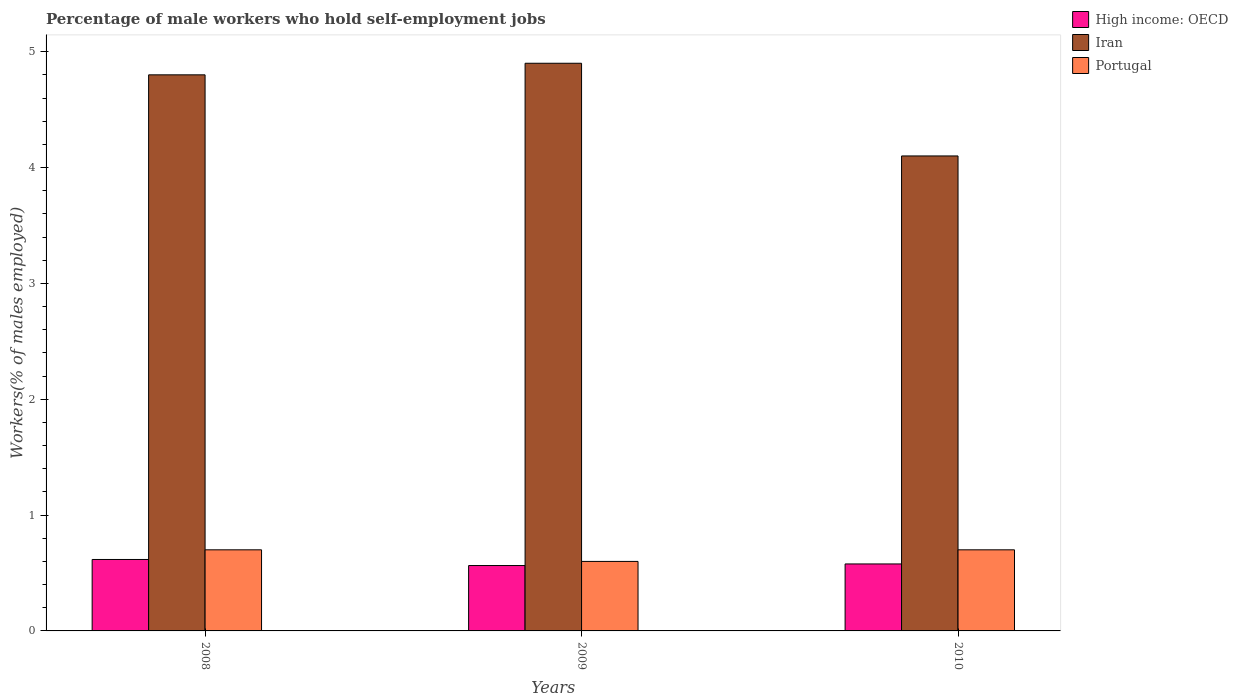How many different coloured bars are there?
Keep it short and to the point. 3. In how many cases, is the number of bars for a given year not equal to the number of legend labels?
Provide a succinct answer. 0. What is the percentage of self-employed male workers in High income: OECD in 2009?
Provide a short and direct response. 0.56. Across all years, what is the maximum percentage of self-employed male workers in Portugal?
Your answer should be very brief. 0.7. Across all years, what is the minimum percentage of self-employed male workers in Iran?
Provide a short and direct response. 4.1. What is the difference between the percentage of self-employed male workers in Iran in 2008 and that in 2010?
Offer a very short reply. 0.7. What is the difference between the percentage of self-employed male workers in Iran in 2008 and the percentage of self-employed male workers in High income: OECD in 2010?
Provide a succinct answer. 4.22. What is the average percentage of self-employed male workers in Portugal per year?
Your answer should be compact. 0.67. In the year 2008, what is the difference between the percentage of self-employed male workers in Portugal and percentage of self-employed male workers in High income: OECD?
Your response must be concise. 0.08. What is the ratio of the percentage of self-employed male workers in Portugal in 2009 to that in 2010?
Your answer should be compact. 0.86. What is the difference between the highest and the second highest percentage of self-employed male workers in High income: OECD?
Your answer should be compact. 0.04. What is the difference between the highest and the lowest percentage of self-employed male workers in Portugal?
Your answer should be compact. 0.1. Is the sum of the percentage of self-employed male workers in Iran in 2009 and 2010 greater than the maximum percentage of self-employed male workers in Portugal across all years?
Offer a terse response. Yes. What does the 1st bar from the left in 2008 represents?
Offer a very short reply. High income: OECD. What does the 2nd bar from the right in 2009 represents?
Your response must be concise. Iran. Is it the case that in every year, the sum of the percentage of self-employed male workers in High income: OECD and percentage of self-employed male workers in Iran is greater than the percentage of self-employed male workers in Portugal?
Make the answer very short. Yes. What is the difference between two consecutive major ticks on the Y-axis?
Offer a terse response. 1. Does the graph contain any zero values?
Provide a short and direct response. No. Does the graph contain grids?
Provide a short and direct response. No. How many legend labels are there?
Provide a succinct answer. 3. What is the title of the graph?
Offer a very short reply. Percentage of male workers who hold self-employment jobs. Does "Austria" appear as one of the legend labels in the graph?
Provide a succinct answer. No. What is the label or title of the Y-axis?
Your answer should be compact. Workers(% of males employed). What is the Workers(% of males employed) of High income: OECD in 2008?
Offer a terse response. 0.62. What is the Workers(% of males employed) of Iran in 2008?
Provide a succinct answer. 4.8. What is the Workers(% of males employed) in Portugal in 2008?
Give a very brief answer. 0.7. What is the Workers(% of males employed) in High income: OECD in 2009?
Offer a very short reply. 0.56. What is the Workers(% of males employed) of Iran in 2009?
Your answer should be very brief. 4.9. What is the Workers(% of males employed) in Portugal in 2009?
Make the answer very short. 0.6. What is the Workers(% of males employed) in High income: OECD in 2010?
Ensure brevity in your answer.  0.58. What is the Workers(% of males employed) of Iran in 2010?
Provide a succinct answer. 4.1. What is the Workers(% of males employed) in Portugal in 2010?
Your answer should be compact. 0.7. Across all years, what is the maximum Workers(% of males employed) of High income: OECD?
Offer a very short reply. 0.62. Across all years, what is the maximum Workers(% of males employed) in Iran?
Keep it short and to the point. 4.9. Across all years, what is the maximum Workers(% of males employed) of Portugal?
Your answer should be very brief. 0.7. Across all years, what is the minimum Workers(% of males employed) in High income: OECD?
Give a very brief answer. 0.56. Across all years, what is the minimum Workers(% of males employed) of Iran?
Your response must be concise. 4.1. Across all years, what is the minimum Workers(% of males employed) in Portugal?
Your answer should be compact. 0.6. What is the total Workers(% of males employed) of High income: OECD in the graph?
Keep it short and to the point. 1.76. What is the total Workers(% of males employed) in Portugal in the graph?
Provide a short and direct response. 2. What is the difference between the Workers(% of males employed) of High income: OECD in 2008 and that in 2009?
Provide a short and direct response. 0.05. What is the difference between the Workers(% of males employed) in Iran in 2008 and that in 2009?
Ensure brevity in your answer.  -0.1. What is the difference between the Workers(% of males employed) in High income: OECD in 2008 and that in 2010?
Provide a succinct answer. 0.04. What is the difference between the Workers(% of males employed) in High income: OECD in 2009 and that in 2010?
Make the answer very short. -0.01. What is the difference between the Workers(% of males employed) of High income: OECD in 2008 and the Workers(% of males employed) of Iran in 2009?
Your answer should be very brief. -4.28. What is the difference between the Workers(% of males employed) in High income: OECD in 2008 and the Workers(% of males employed) in Portugal in 2009?
Make the answer very short. 0.02. What is the difference between the Workers(% of males employed) in High income: OECD in 2008 and the Workers(% of males employed) in Iran in 2010?
Offer a very short reply. -3.48. What is the difference between the Workers(% of males employed) of High income: OECD in 2008 and the Workers(% of males employed) of Portugal in 2010?
Your answer should be compact. -0.08. What is the difference between the Workers(% of males employed) of Iran in 2008 and the Workers(% of males employed) of Portugal in 2010?
Provide a short and direct response. 4.1. What is the difference between the Workers(% of males employed) of High income: OECD in 2009 and the Workers(% of males employed) of Iran in 2010?
Your answer should be compact. -3.54. What is the difference between the Workers(% of males employed) of High income: OECD in 2009 and the Workers(% of males employed) of Portugal in 2010?
Your answer should be very brief. -0.14. What is the difference between the Workers(% of males employed) in Iran in 2009 and the Workers(% of males employed) in Portugal in 2010?
Your answer should be very brief. 4.2. What is the average Workers(% of males employed) in High income: OECD per year?
Make the answer very short. 0.59. What is the average Workers(% of males employed) of Portugal per year?
Ensure brevity in your answer.  0.67. In the year 2008, what is the difference between the Workers(% of males employed) in High income: OECD and Workers(% of males employed) in Iran?
Offer a terse response. -4.18. In the year 2008, what is the difference between the Workers(% of males employed) of High income: OECD and Workers(% of males employed) of Portugal?
Give a very brief answer. -0.08. In the year 2009, what is the difference between the Workers(% of males employed) of High income: OECD and Workers(% of males employed) of Iran?
Ensure brevity in your answer.  -4.34. In the year 2009, what is the difference between the Workers(% of males employed) in High income: OECD and Workers(% of males employed) in Portugal?
Your answer should be very brief. -0.04. In the year 2009, what is the difference between the Workers(% of males employed) of Iran and Workers(% of males employed) of Portugal?
Provide a succinct answer. 4.3. In the year 2010, what is the difference between the Workers(% of males employed) of High income: OECD and Workers(% of males employed) of Iran?
Provide a short and direct response. -3.52. In the year 2010, what is the difference between the Workers(% of males employed) in High income: OECD and Workers(% of males employed) in Portugal?
Ensure brevity in your answer.  -0.12. In the year 2010, what is the difference between the Workers(% of males employed) of Iran and Workers(% of males employed) of Portugal?
Provide a succinct answer. 3.4. What is the ratio of the Workers(% of males employed) in High income: OECD in 2008 to that in 2009?
Provide a short and direct response. 1.09. What is the ratio of the Workers(% of males employed) of Iran in 2008 to that in 2009?
Offer a very short reply. 0.98. What is the ratio of the Workers(% of males employed) in High income: OECD in 2008 to that in 2010?
Give a very brief answer. 1.07. What is the ratio of the Workers(% of males employed) of Iran in 2008 to that in 2010?
Make the answer very short. 1.17. What is the ratio of the Workers(% of males employed) of Portugal in 2008 to that in 2010?
Give a very brief answer. 1. What is the ratio of the Workers(% of males employed) of High income: OECD in 2009 to that in 2010?
Your response must be concise. 0.98. What is the ratio of the Workers(% of males employed) in Iran in 2009 to that in 2010?
Provide a short and direct response. 1.2. What is the ratio of the Workers(% of males employed) in Portugal in 2009 to that in 2010?
Provide a short and direct response. 0.86. What is the difference between the highest and the second highest Workers(% of males employed) of High income: OECD?
Make the answer very short. 0.04. What is the difference between the highest and the second highest Workers(% of males employed) of Iran?
Give a very brief answer. 0.1. What is the difference between the highest and the second highest Workers(% of males employed) in Portugal?
Provide a succinct answer. 0. What is the difference between the highest and the lowest Workers(% of males employed) of High income: OECD?
Offer a terse response. 0.05. What is the difference between the highest and the lowest Workers(% of males employed) in Iran?
Provide a short and direct response. 0.8. 